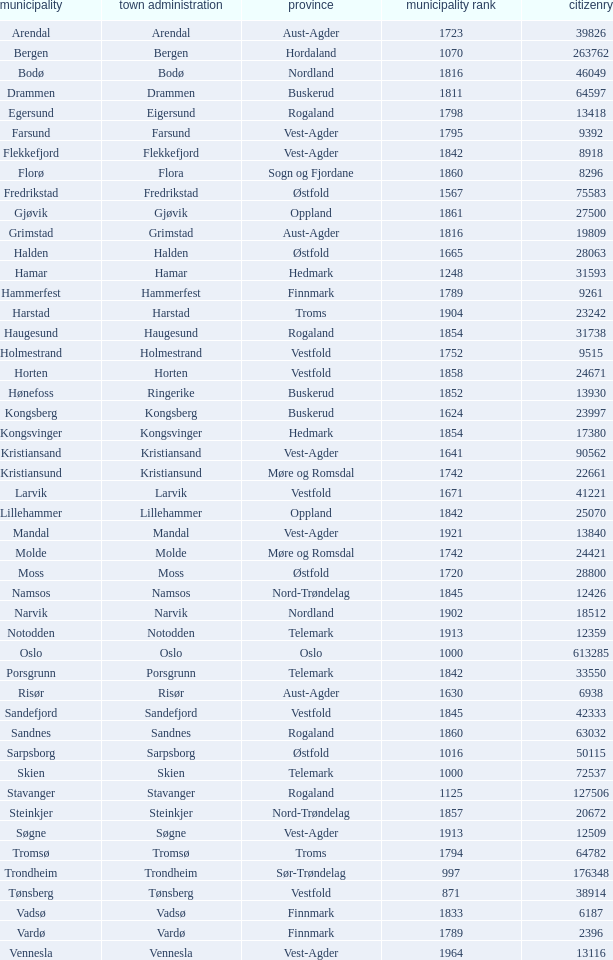Can you parse all the data within this table? {'header': ['municipality', 'town administration', 'province', 'municipality rank', 'citizenry'], 'rows': [['Arendal', 'Arendal', 'Aust-Agder', '1723', '39826'], ['Bergen', 'Bergen', 'Hordaland', '1070', '263762'], ['Bodø', 'Bodø', 'Nordland', '1816', '46049'], ['Drammen', 'Drammen', 'Buskerud', '1811', '64597'], ['Egersund', 'Eigersund', 'Rogaland', '1798', '13418'], ['Farsund', 'Farsund', 'Vest-Agder', '1795', '9392'], ['Flekkefjord', 'Flekkefjord', 'Vest-Agder', '1842', '8918'], ['Florø', 'Flora', 'Sogn og Fjordane', '1860', '8296'], ['Fredrikstad', 'Fredrikstad', 'Østfold', '1567', '75583'], ['Gjøvik', 'Gjøvik', 'Oppland', '1861', '27500'], ['Grimstad', 'Grimstad', 'Aust-Agder', '1816', '19809'], ['Halden', 'Halden', 'Østfold', '1665', '28063'], ['Hamar', 'Hamar', 'Hedmark', '1248', '31593'], ['Hammerfest', 'Hammerfest', 'Finnmark', '1789', '9261'], ['Harstad', 'Harstad', 'Troms', '1904', '23242'], ['Haugesund', 'Haugesund', 'Rogaland', '1854', '31738'], ['Holmestrand', 'Holmestrand', 'Vestfold', '1752', '9515'], ['Horten', 'Horten', 'Vestfold', '1858', '24671'], ['Hønefoss', 'Ringerike', 'Buskerud', '1852', '13930'], ['Kongsberg', 'Kongsberg', 'Buskerud', '1624', '23997'], ['Kongsvinger', 'Kongsvinger', 'Hedmark', '1854', '17380'], ['Kristiansand', 'Kristiansand', 'Vest-Agder', '1641', '90562'], ['Kristiansund', 'Kristiansund', 'Møre og Romsdal', '1742', '22661'], ['Larvik', 'Larvik', 'Vestfold', '1671', '41221'], ['Lillehammer', 'Lillehammer', 'Oppland', '1842', '25070'], ['Mandal', 'Mandal', 'Vest-Agder', '1921', '13840'], ['Molde', 'Molde', 'Møre og Romsdal', '1742', '24421'], ['Moss', 'Moss', 'Østfold', '1720', '28800'], ['Namsos', 'Namsos', 'Nord-Trøndelag', '1845', '12426'], ['Narvik', 'Narvik', 'Nordland', '1902', '18512'], ['Notodden', 'Notodden', 'Telemark', '1913', '12359'], ['Oslo', 'Oslo', 'Oslo', '1000', '613285'], ['Porsgrunn', 'Porsgrunn', 'Telemark', '1842', '33550'], ['Risør', 'Risør', 'Aust-Agder', '1630', '6938'], ['Sandefjord', 'Sandefjord', 'Vestfold', '1845', '42333'], ['Sandnes', 'Sandnes', 'Rogaland', '1860', '63032'], ['Sarpsborg', 'Sarpsborg', 'Østfold', '1016', '50115'], ['Skien', 'Skien', 'Telemark', '1000', '72537'], ['Stavanger', 'Stavanger', 'Rogaland', '1125', '127506'], ['Steinkjer', 'Steinkjer', 'Nord-Trøndelag', '1857', '20672'], ['Søgne', 'Søgne', 'Vest-Agder', '1913', '12509'], ['Tromsø', 'Tromsø', 'Troms', '1794', '64782'], ['Trondheim', 'Trondheim', 'Sør-Trøndelag', '997', '176348'], ['Tønsberg', 'Tønsberg', 'Vestfold', '871', '38914'], ['Vadsø', 'Vadsø', 'Finnmark', '1833', '6187'], ['Vardø', 'Vardø', 'Finnmark', '1789', '2396'], ['Vennesla', 'Vennesla', 'Vest-Agder', '1964', '13116']]} What are the cities/towns located in the municipality of Moss? Moss. 